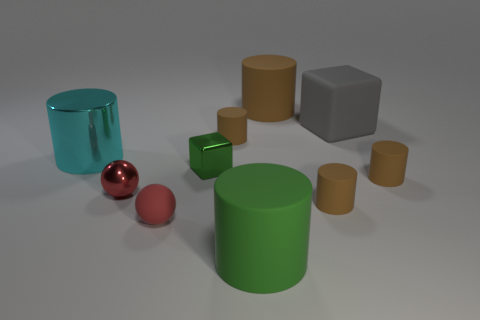Subtract all brown blocks. How many brown cylinders are left? 4 Subtract all cyan cylinders. How many cylinders are left? 5 Subtract all big cyan shiny cylinders. How many cylinders are left? 5 Subtract all green cylinders. Subtract all cyan blocks. How many cylinders are left? 5 Subtract all cubes. How many objects are left? 8 Add 6 red shiny spheres. How many red shiny spheres exist? 7 Subtract 0 brown cubes. How many objects are left? 10 Subtract all large red metallic blocks. Subtract all small red matte balls. How many objects are left? 9 Add 5 gray matte things. How many gray matte things are left? 6 